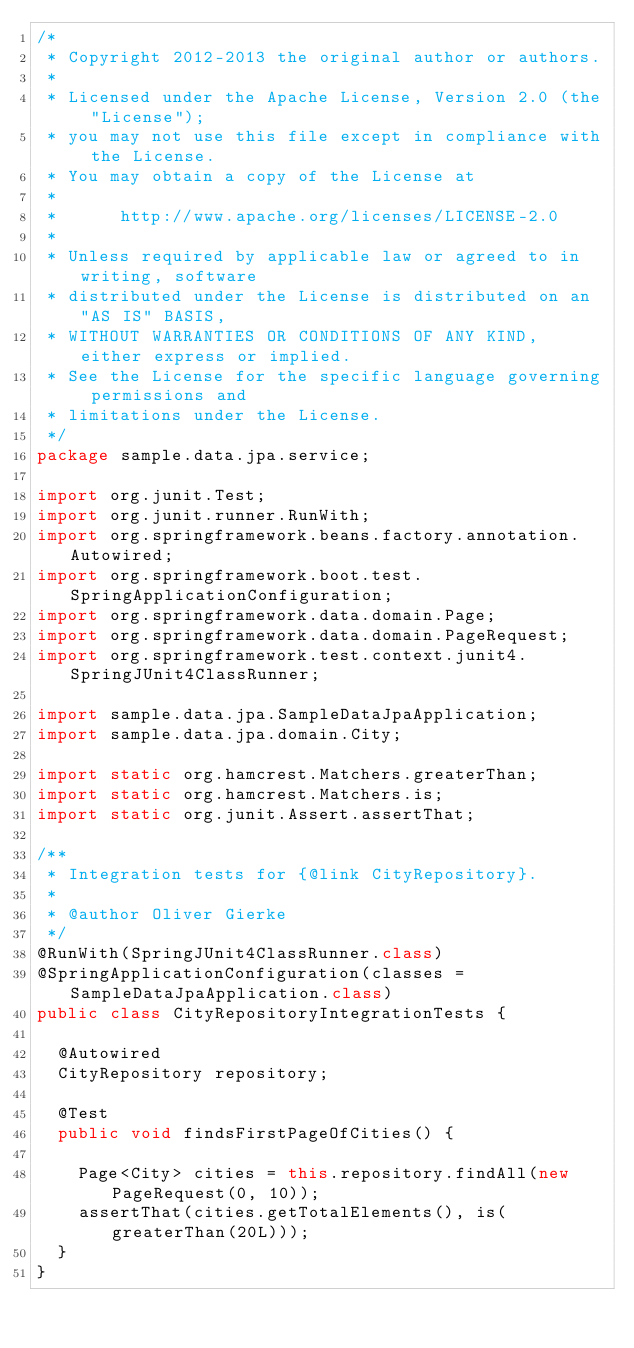Convert code to text. <code><loc_0><loc_0><loc_500><loc_500><_Java_>/*
 * Copyright 2012-2013 the original author or authors.
 *
 * Licensed under the Apache License, Version 2.0 (the "License");
 * you may not use this file except in compliance with the License.
 * You may obtain a copy of the License at
 *
 *      http://www.apache.org/licenses/LICENSE-2.0
 *
 * Unless required by applicable law or agreed to in writing, software
 * distributed under the License is distributed on an "AS IS" BASIS,
 * WITHOUT WARRANTIES OR CONDITIONS OF ANY KIND, either express or implied.
 * See the License for the specific language governing permissions and
 * limitations under the License.
 */
package sample.data.jpa.service;

import org.junit.Test;
import org.junit.runner.RunWith;
import org.springframework.beans.factory.annotation.Autowired;
import org.springframework.boot.test.SpringApplicationConfiguration;
import org.springframework.data.domain.Page;
import org.springframework.data.domain.PageRequest;
import org.springframework.test.context.junit4.SpringJUnit4ClassRunner;

import sample.data.jpa.SampleDataJpaApplication;
import sample.data.jpa.domain.City;

import static org.hamcrest.Matchers.greaterThan;
import static org.hamcrest.Matchers.is;
import static org.junit.Assert.assertThat;

/**
 * Integration tests for {@link CityRepository}.
 *
 * @author Oliver Gierke
 */
@RunWith(SpringJUnit4ClassRunner.class)
@SpringApplicationConfiguration(classes = SampleDataJpaApplication.class)
public class CityRepositoryIntegrationTests {

	@Autowired
	CityRepository repository;

	@Test
	public void findsFirstPageOfCities() {

		Page<City> cities = this.repository.findAll(new PageRequest(0, 10));
		assertThat(cities.getTotalElements(), is(greaterThan(20L)));
	}
}
</code> 